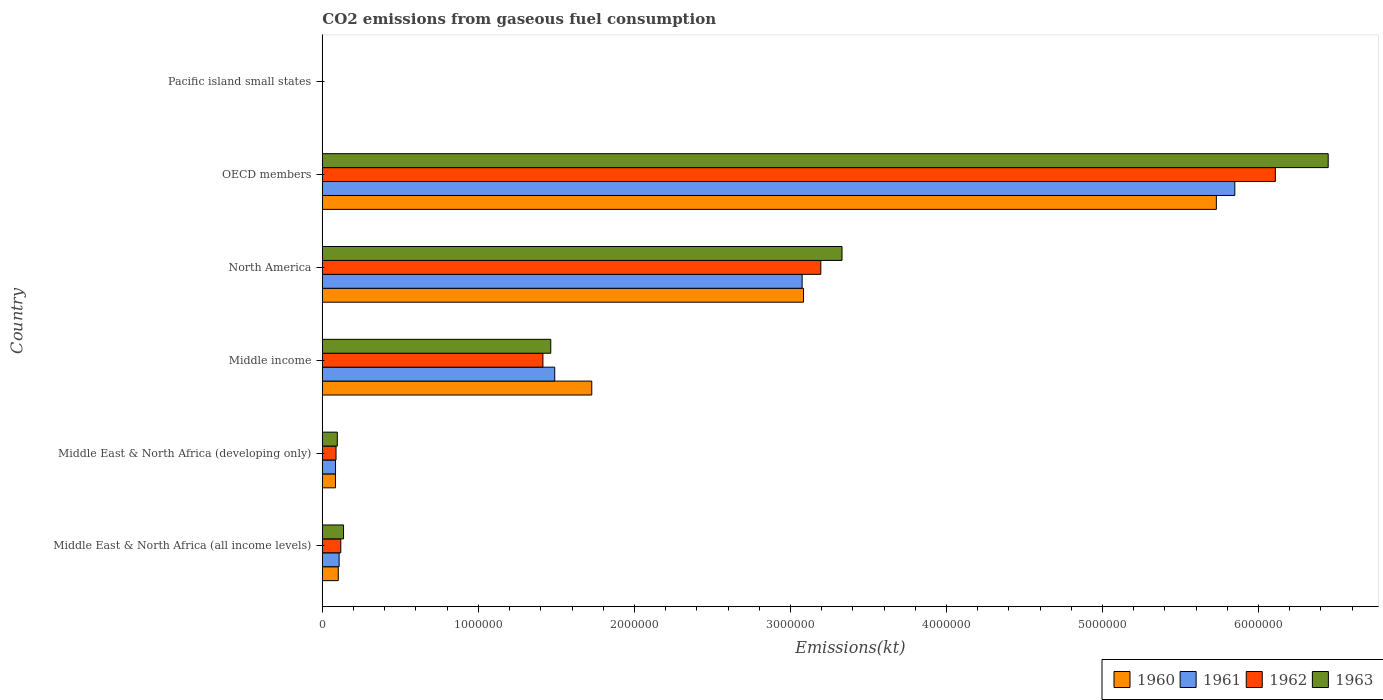How many groups of bars are there?
Make the answer very short. 6. How many bars are there on the 6th tick from the bottom?
Provide a succinct answer. 4. What is the label of the 4th group of bars from the top?
Your answer should be very brief. Middle income. What is the amount of CO2 emitted in 1961 in Middle income?
Make the answer very short. 1.49e+06. Across all countries, what is the maximum amount of CO2 emitted in 1961?
Ensure brevity in your answer.  5.85e+06. Across all countries, what is the minimum amount of CO2 emitted in 1961?
Offer a terse response. 332.61. In which country was the amount of CO2 emitted in 1960 maximum?
Your answer should be compact. OECD members. In which country was the amount of CO2 emitted in 1960 minimum?
Offer a terse response. Pacific island small states. What is the total amount of CO2 emitted in 1960 in the graph?
Keep it short and to the point. 1.07e+07. What is the difference between the amount of CO2 emitted in 1962 in Middle income and that in OECD members?
Offer a terse response. -4.69e+06. What is the difference between the amount of CO2 emitted in 1963 in Middle East & North Africa (all income levels) and the amount of CO2 emitted in 1960 in Middle East & North Africa (developing only)?
Offer a very short reply. 5.17e+04. What is the average amount of CO2 emitted in 1963 per country?
Provide a short and direct response. 1.91e+06. What is the difference between the amount of CO2 emitted in 1961 and amount of CO2 emitted in 1963 in OECD members?
Offer a terse response. -5.99e+05. In how many countries, is the amount of CO2 emitted in 1963 greater than 200000 kt?
Offer a terse response. 3. What is the ratio of the amount of CO2 emitted in 1961 in Middle income to that in North America?
Provide a short and direct response. 0.48. Is the amount of CO2 emitted in 1961 in OECD members less than that in Pacific island small states?
Your response must be concise. No. Is the difference between the amount of CO2 emitted in 1961 in Middle East & North Africa (all income levels) and Middle income greater than the difference between the amount of CO2 emitted in 1963 in Middle East & North Africa (all income levels) and Middle income?
Your response must be concise. No. What is the difference between the highest and the second highest amount of CO2 emitted in 1962?
Provide a short and direct response. 2.91e+06. What is the difference between the highest and the lowest amount of CO2 emitted in 1961?
Make the answer very short. 5.85e+06. In how many countries, is the amount of CO2 emitted in 1960 greater than the average amount of CO2 emitted in 1960 taken over all countries?
Your answer should be compact. 2. Is the sum of the amount of CO2 emitted in 1962 in Middle East & North Africa (all income levels) and Middle East & North Africa (developing only) greater than the maximum amount of CO2 emitted in 1963 across all countries?
Give a very brief answer. No. Is it the case that in every country, the sum of the amount of CO2 emitted in 1963 and amount of CO2 emitted in 1960 is greater than the sum of amount of CO2 emitted in 1962 and amount of CO2 emitted in 1961?
Give a very brief answer. No. What does the 3rd bar from the bottom in OECD members represents?
Provide a short and direct response. 1962. What is the difference between two consecutive major ticks on the X-axis?
Ensure brevity in your answer.  1.00e+06. Are the values on the major ticks of X-axis written in scientific E-notation?
Provide a succinct answer. No. Where does the legend appear in the graph?
Make the answer very short. Bottom right. How are the legend labels stacked?
Make the answer very short. Horizontal. What is the title of the graph?
Give a very brief answer. CO2 emissions from gaseous fuel consumption. Does "2000" appear as one of the legend labels in the graph?
Your answer should be compact. No. What is the label or title of the X-axis?
Provide a short and direct response. Emissions(kt). What is the label or title of the Y-axis?
Your answer should be very brief. Country. What is the Emissions(kt) in 1960 in Middle East & North Africa (all income levels)?
Give a very brief answer. 1.02e+05. What is the Emissions(kt) in 1961 in Middle East & North Africa (all income levels)?
Keep it short and to the point. 1.07e+05. What is the Emissions(kt) of 1962 in Middle East & North Africa (all income levels)?
Keep it short and to the point. 1.18e+05. What is the Emissions(kt) in 1963 in Middle East & North Africa (all income levels)?
Your answer should be very brief. 1.36e+05. What is the Emissions(kt) of 1960 in Middle East & North Africa (developing only)?
Your answer should be compact. 8.42e+04. What is the Emissions(kt) of 1961 in Middle East & North Africa (developing only)?
Offer a terse response. 8.46e+04. What is the Emissions(kt) in 1962 in Middle East & North Africa (developing only)?
Offer a terse response. 8.78e+04. What is the Emissions(kt) in 1963 in Middle East & North Africa (developing only)?
Make the answer very short. 9.60e+04. What is the Emissions(kt) in 1960 in Middle income?
Your answer should be compact. 1.73e+06. What is the Emissions(kt) of 1961 in Middle income?
Your answer should be very brief. 1.49e+06. What is the Emissions(kt) of 1962 in Middle income?
Offer a very short reply. 1.41e+06. What is the Emissions(kt) of 1963 in Middle income?
Keep it short and to the point. 1.46e+06. What is the Emissions(kt) in 1960 in North America?
Offer a very short reply. 3.08e+06. What is the Emissions(kt) in 1961 in North America?
Provide a succinct answer. 3.07e+06. What is the Emissions(kt) of 1962 in North America?
Give a very brief answer. 3.19e+06. What is the Emissions(kt) of 1963 in North America?
Provide a succinct answer. 3.33e+06. What is the Emissions(kt) of 1960 in OECD members?
Your answer should be very brief. 5.73e+06. What is the Emissions(kt) of 1961 in OECD members?
Keep it short and to the point. 5.85e+06. What is the Emissions(kt) of 1962 in OECD members?
Your answer should be compact. 6.11e+06. What is the Emissions(kt) of 1963 in OECD members?
Offer a terse response. 6.45e+06. What is the Emissions(kt) in 1960 in Pacific island small states?
Provide a short and direct response. 309.51. What is the Emissions(kt) of 1961 in Pacific island small states?
Make the answer very short. 332.61. What is the Emissions(kt) in 1962 in Pacific island small states?
Provide a succinct answer. 413.52. What is the Emissions(kt) of 1963 in Pacific island small states?
Keep it short and to the point. 433.59. Across all countries, what is the maximum Emissions(kt) of 1960?
Give a very brief answer. 5.73e+06. Across all countries, what is the maximum Emissions(kt) of 1961?
Your answer should be compact. 5.85e+06. Across all countries, what is the maximum Emissions(kt) of 1962?
Offer a terse response. 6.11e+06. Across all countries, what is the maximum Emissions(kt) of 1963?
Your answer should be very brief. 6.45e+06. Across all countries, what is the minimum Emissions(kt) of 1960?
Offer a very short reply. 309.51. Across all countries, what is the minimum Emissions(kt) of 1961?
Provide a succinct answer. 332.61. Across all countries, what is the minimum Emissions(kt) in 1962?
Keep it short and to the point. 413.52. Across all countries, what is the minimum Emissions(kt) in 1963?
Provide a short and direct response. 433.59. What is the total Emissions(kt) in 1960 in the graph?
Offer a very short reply. 1.07e+07. What is the total Emissions(kt) of 1961 in the graph?
Your response must be concise. 1.06e+07. What is the total Emissions(kt) in 1962 in the graph?
Make the answer very short. 1.09e+07. What is the total Emissions(kt) in 1963 in the graph?
Your answer should be very brief. 1.15e+07. What is the difference between the Emissions(kt) of 1960 in Middle East & North Africa (all income levels) and that in Middle East & North Africa (developing only)?
Your answer should be compact. 1.80e+04. What is the difference between the Emissions(kt) of 1961 in Middle East & North Africa (all income levels) and that in Middle East & North Africa (developing only)?
Your response must be concise. 2.29e+04. What is the difference between the Emissions(kt) in 1962 in Middle East & North Africa (all income levels) and that in Middle East & North Africa (developing only)?
Keep it short and to the point. 3.06e+04. What is the difference between the Emissions(kt) of 1963 in Middle East & North Africa (all income levels) and that in Middle East & North Africa (developing only)?
Provide a short and direct response. 4.00e+04. What is the difference between the Emissions(kt) in 1960 in Middle East & North Africa (all income levels) and that in Middle income?
Provide a succinct answer. -1.62e+06. What is the difference between the Emissions(kt) in 1961 in Middle East & North Africa (all income levels) and that in Middle income?
Provide a short and direct response. -1.38e+06. What is the difference between the Emissions(kt) of 1962 in Middle East & North Africa (all income levels) and that in Middle income?
Offer a very short reply. -1.30e+06. What is the difference between the Emissions(kt) in 1963 in Middle East & North Africa (all income levels) and that in Middle income?
Keep it short and to the point. -1.33e+06. What is the difference between the Emissions(kt) of 1960 in Middle East & North Africa (all income levels) and that in North America?
Offer a terse response. -2.98e+06. What is the difference between the Emissions(kt) in 1961 in Middle East & North Africa (all income levels) and that in North America?
Give a very brief answer. -2.97e+06. What is the difference between the Emissions(kt) in 1962 in Middle East & North Africa (all income levels) and that in North America?
Provide a short and direct response. -3.08e+06. What is the difference between the Emissions(kt) of 1963 in Middle East & North Africa (all income levels) and that in North America?
Provide a succinct answer. -3.19e+06. What is the difference between the Emissions(kt) of 1960 in Middle East & North Africa (all income levels) and that in OECD members?
Make the answer very short. -5.63e+06. What is the difference between the Emissions(kt) in 1961 in Middle East & North Africa (all income levels) and that in OECD members?
Your answer should be very brief. -5.74e+06. What is the difference between the Emissions(kt) of 1962 in Middle East & North Africa (all income levels) and that in OECD members?
Provide a short and direct response. -5.99e+06. What is the difference between the Emissions(kt) of 1963 in Middle East & North Africa (all income levels) and that in OECD members?
Offer a terse response. -6.31e+06. What is the difference between the Emissions(kt) of 1960 in Middle East & North Africa (all income levels) and that in Pacific island small states?
Your answer should be compact. 1.02e+05. What is the difference between the Emissions(kt) in 1961 in Middle East & North Africa (all income levels) and that in Pacific island small states?
Your answer should be very brief. 1.07e+05. What is the difference between the Emissions(kt) of 1962 in Middle East & North Africa (all income levels) and that in Pacific island small states?
Ensure brevity in your answer.  1.18e+05. What is the difference between the Emissions(kt) in 1963 in Middle East & North Africa (all income levels) and that in Pacific island small states?
Provide a succinct answer. 1.36e+05. What is the difference between the Emissions(kt) of 1960 in Middle East & North Africa (developing only) and that in Middle income?
Keep it short and to the point. -1.64e+06. What is the difference between the Emissions(kt) in 1961 in Middle East & North Africa (developing only) and that in Middle income?
Your answer should be very brief. -1.40e+06. What is the difference between the Emissions(kt) of 1962 in Middle East & North Africa (developing only) and that in Middle income?
Offer a very short reply. -1.33e+06. What is the difference between the Emissions(kt) of 1963 in Middle East & North Africa (developing only) and that in Middle income?
Your response must be concise. -1.37e+06. What is the difference between the Emissions(kt) in 1960 in Middle East & North Africa (developing only) and that in North America?
Give a very brief answer. -3.00e+06. What is the difference between the Emissions(kt) in 1961 in Middle East & North Africa (developing only) and that in North America?
Your answer should be compact. -2.99e+06. What is the difference between the Emissions(kt) of 1962 in Middle East & North Africa (developing only) and that in North America?
Keep it short and to the point. -3.11e+06. What is the difference between the Emissions(kt) in 1963 in Middle East & North Africa (developing only) and that in North America?
Offer a very short reply. -3.23e+06. What is the difference between the Emissions(kt) in 1960 in Middle East & North Africa (developing only) and that in OECD members?
Provide a short and direct response. -5.65e+06. What is the difference between the Emissions(kt) in 1961 in Middle East & North Africa (developing only) and that in OECD members?
Provide a succinct answer. -5.76e+06. What is the difference between the Emissions(kt) in 1962 in Middle East & North Africa (developing only) and that in OECD members?
Provide a succinct answer. -6.02e+06. What is the difference between the Emissions(kt) in 1963 in Middle East & North Africa (developing only) and that in OECD members?
Make the answer very short. -6.35e+06. What is the difference between the Emissions(kt) in 1960 in Middle East & North Africa (developing only) and that in Pacific island small states?
Make the answer very short. 8.39e+04. What is the difference between the Emissions(kt) in 1961 in Middle East & North Africa (developing only) and that in Pacific island small states?
Offer a terse response. 8.43e+04. What is the difference between the Emissions(kt) of 1962 in Middle East & North Africa (developing only) and that in Pacific island small states?
Provide a short and direct response. 8.74e+04. What is the difference between the Emissions(kt) of 1963 in Middle East & North Africa (developing only) and that in Pacific island small states?
Provide a short and direct response. 9.56e+04. What is the difference between the Emissions(kt) in 1960 in Middle income and that in North America?
Offer a terse response. -1.36e+06. What is the difference between the Emissions(kt) in 1961 in Middle income and that in North America?
Your response must be concise. -1.59e+06. What is the difference between the Emissions(kt) of 1962 in Middle income and that in North America?
Your answer should be very brief. -1.78e+06. What is the difference between the Emissions(kt) of 1963 in Middle income and that in North America?
Your answer should be very brief. -1.87e+06. What is the difference between the Emissions(kt) in 1960 in Middle income and that in OECD members?
Ensure brevity in your answer.  -4.00e+06. What is the difference between the Emissions(kt) in 1961 in Middle income and that in OECD members?
Offer a very short reply. -4.36e+06. What is the difference between the Emissions(kt) in 1962 in Middle income and that in OECD members?
Keep it short and to the point. -4.69e+06. What is the difference between the Emissions(kt) of 1963 in Middle income and that in OECD members?
Your response must be concise. -4.98e+06. What is the difference between the Emissions(kt) of 1960 in Middle income and that in Pacific island small states?
Your answer should be compact. 1.73e+06. What is the difference between the Emissions(kt) of 1961 in Middle income and that in Pacific island small states?
Ensure brevity in your answer.  1.49e+06. What is the difference between the Emissions(kt) of 1962 in Middle income and that in Pacific island small states?
Your answer should be very brief. 1.41e+06. What is the difference between the Emissions(kt) in 1963 in Middle income and that in Pacific island small states?
Your answer should be very brief. 1.46e+06. What is the difference between the Emissions(kt) of 1960 in North America and that in OECD members?
Ensure brevity in your answer.  -2.65e+06. What is the difference between the Emissions(kt) in 1961 in North America and that in OECD members?
Your answer should be very brief. -2.77e+06. What is the difference between the Emissions(kt) in 1962 in North America and that in OECD members?
Your response must be concise. -2.91e+06. What is the difference between the Emissions(kt) in 1963 in North America and that in OECD members?
Keep it short and to the point. -3.12e+06. What is the difference between the Emissions(kt) in 1960 in North America and that in Pacific island small states?
Your answer should be compact. 3.08e+06. What is the difference between the Emissions(kt) of 1961 in North America and that in Pacific island small states?
Your response must be concise. 3.07e+06. What is the difference between the Emissions(kt) in 1962 in North America and that in Pacific island small states?
Offer a terse response. 3.19e+06. What is the difference between the Emissions(kt) of 1963 in North America and that in Pacific island small states?
Provide a succinct answer. 3.33e+06. What is the difference between the Emissions(kt) in 1960 in OECD members and that in Pacific island small states?
Give a very brief answer. 5.73e+06. What is the difference between the Emissions(kt) of 1961 in OECD members and that in Pacific island small states?
Ensure brevity in your answer.  5.85e+06. What is the difference between the Emissions(kt) in 1962 in OECD members and that in Pacific island small states?
Your answer should be very brief. 6.11e+06. What is the difference between the Emissions(kt) in 1963 in OECD members and that in Pacific island small states?
Ensure brevity in your answer.  6.45e+06. What is the difference between the Emissions(kt) of 1960 in Middle East & North Africa (all income levels) and the Emissions(kt) of 1961 in Middle East & North Africa (developing only)?
Your answer should be compact. 1.76e+04. What is the difference between the Emissions(kt) of 1960 in Middle East & North Africa (all income levels) and the Emissions(kt) of 1962 in Middle East & North Africa (developing only)?
Provide a short and direct response. 1.45e+04. What is the difference between the Emissions(kt) in 1960 in Middle East & North Africa (all income levels) and the Emissions(kt) in 1963 in Middle East & North Africa (developing only)?
Keep it short and to the point. 6263.25. What is the difference between the Emissions(kt) of 1961 in Middle East & North Africa (all income levels) and the Emissions(kt) of 1962 in Middle East & North Africa (developing only)?
Offer a terse response. 1.97e+04. What is the difference between the Emissions(kt) of 1961 in Middle East & North Africa (all income levels) and the Emissions(kt) of 1963 in Middle East & North Africa (developing only)?
Offer a terse response. 1.15e+04. What is the difference between the Emissions(kt) of 1962 in Middle East & North Africa (all income levels) and the Emissions(kt) of 1963 in Middle East & North Africa (developing only)?
Your answer should be compact. 2.24e+04. What is the difference between the Emissions(kt) of 1960 in Middle East & North Africa (all income levels) and the Emissions(kt) of 1961 in Middle income?
Offer a terse response. -1.39e+06. What is the difference between the Emissions(kt) of 1960 in Middle East & North Africa (all income levels) and the Emissions(kt) of 1962 in Middle income?
Make the answer very short. -1.31e+06. What is the difference between the Emissions(kt) of 1960 in Middle East & North Africa (all income levels) and the Emissions(kt) of 1963 in Middle income?
Offer a very short reply. -1.36e+06. What is the difference between the Emissions(kt) in 1961 in Middle East & North Africa (all income levels) and the Emissions(kt) in 1962 in Middle income?
Your answer should be compact. -1.31e+06. What is the difference between the Emissions(kt) of 1961 in Middle East & North Africa (all income levels) and the Emissions(kt) of 1963 in Middle income?
Keep it short and to the point. -1.36e+06. What is the difference between the Emissions(kt) of 1962 in Middle East & North Africa (all income levels) and the Emissions(kt) of 1963 in Middle income?
Your answer should be very brief. -1.35e+06. What is the difference between the Emissions(kt) of 1960 in Middle East & North Africa (all income levels) and the Emissions(kt) of 1961 in North America?
Ensure brevity in your answer.  -2.97e+06. What is the difference between the Emissions(kt) in 1960 in Middle East & North Africa (all income levels) and the Emissions(kt) in 1962 in North America?
Your response must be concise. -3.09e+06. What is the difference between the Emissions(kt) of 1960 in Middle East & North Africa (all income levels) and the Emissions(kt) of 1963 in North America?
Offer a terse response. -3.23e+06. What is the difference between the Emissions(kt) of 1961 in Middle East & North Africa (all income levels) and the Emissions(kt) of 1962 in North America?
Give a very brief answer. -3.09e+06. What is the difference between the Emissions(kt) of 1961 in Middle East & North Africa (all income levels) and the Emissions(kt) of 1963 in North America?
Provide a succinct answer. -3.22e+06. What is the difference between the Emissions(kt) in 1962 in Middle East & North Africa (all income levels) and the Emissions(kt) in 1963 in North America?
Keep it short and to the point. -3.21e+06. What is the difference between the Emissions(kt) of 1960 in Middle East & North Africa (all income levels) and the Emissions(kt) of 1961 in OECD members?
Your answer should be compact. -5.75e+06. What is the difference between the Emissions(kt) in 1960 in Middle East & North Africa (all income levels) and the Emissions(kt) in 1962 in OECD members?
Keep it short and to the point. -6.01e+06. What is the difference between the Emissions(kt) of 1960 in Middle East & North Africa (all income levels) and the Emissions(kt) of 1963 in OECD members?
Your answer should be compact. -6.34e+06. What is the difference between the Emissions(kt) in 1961 in Middle East & North Africa (all income levels) and the Emissions(kt) in 1962 in OECD members?
Your answer should be very brief. -6.00e+06. What is the difference between the Emissions(kt) in 1961 in Middle East & North Africa (all income levels) and the Emissions(kt) in 1963 in OECD members?
Offer a terse response. -6.34e+06. What is the difference between the Emissions(kt) in 1962 in Middle East & North Africa (all income levels) and the Emissions(kt) in 1963 in OECD members?
Provide a succinct answer. -6.33e+06. What is the difference between the Emissions(kt) of 1960 in Middle East & North Africa (all income levels) and the Emissions(kt) of 1961 in Pacific island small states?
Your response must be concise. 1.02e+05. What is the difference between the Emissions(kt) of 1960 in Middle East & North Africa (all income levels) and the Emissions(kt) of 1962 in Pacific island small states?
Make the answer very short. 1.02e+05. What is the difference between the Emissions(kt) in 1960 in Middle East & North Africa (all income levels) and the Emissions(kt) in 1963 in Pacific island small states?
Ensure brevity in your answer.  1.02e+05. What is the difference between the Emissions(kt) of 1961 in Middle East & North Africa (all income levels) and the Emissions(kt) of 1962 in Pacific island small states?
Ensure brevity in your answer.  1.07e+05. What is the difference between the Emissions(kt) of 1961 in Middle East & North Africa (all income levels) and the Emissions(kt) of 1963 in Pacific island small states?
Offer a very short reply. 1.07e+05. What is the difference between the Emissions(kt) in 1962 in Middle East & North Africa (all income levels) and the Emissions(kt) in 1963 in Pacific island small states?
Provide a short and direct response. 1.18e+05. What is the difference between the Emissions(kt) of 1960 in Middle East & North Africa (developing only) and the Emissions(kt) of 1961 in Middle income?
Your response must be concise. -1.41e+06. What is the difference between the Emissions(kt) in 1960 in Middle East & North Africa (developing only) and the Emissions(kt) in 1962 in Middle income?
Offer a very short reply. -1.33e+06. What is the difference between the Emissions(kt) of 1960 in Middle East & North Africa (developing only) and the Emissions(kt) of 1963 in Middle income?
Your response must be concise. -1.38e+06. What is the difference between the Emissions(kt) of 1961 in Middle East & North Africa (developing only) and the Emissions(kt) of 1962 in Middle income?
Provide a succinct answer. -1.33e+06. What is the difference between the Emissions(kt) in 1961 in Middle East & North Africa (developing only) and the Emissions(kt) in 1963 in Middle income?
Make the answer very short. -1.38e+06. What is the difference between the Emissions(kt) of 1962 in Middle East & North Africa (developing only) and the Emissions(kt) of 1963 in Middle income?
Make the answer very short. -1.38e+06. What is the difference between the Emissions(kt) in 1960 in Middle East & North Africa (developing only) and the Emissions(kt) in 1961 in North America?
Your answer should be compact. -2.99e+06. What is the difference between the Emissions(kt) of 1960 in Middle East & North Africa (developing only) and the Emissions(kt) of 1962 in North America?
Your answer should be very brief. -3.11e+06. What is the difference between the Emissions(kt) in 1960 in Middle East & North Africa (developing only) and the Emissions(kt) in 1963 in North America?
Ensure brevity in your answer.  -3.25e+06. What is the difference between the Emissions(kt) in 1961 in Middle East & North Africa (developing only) and the Emissions(kt) in 1962 in North America?
Make the answer very short. -3.11e+06. What is the difference between the Emissions(kt) of 1961 in Middle East & North Africa (developing only) and the Emissions(kt) of 1963 in North America?
Keep it short and to the point. -3.25e+06. What is the difference between the Emissions(kt) in 1962 in Middle East & North Africa (developing only) and the Emissions(kt) in 1963 in North America?
Give a very brief answer. -3.24e+06. What is the difference between the Emissions(kt) of 1960 in Middle East & North Africa (developing only) and the Emissions(kt) of 1961 in OECD members?
Your answer should be very brief. -5.76e+06. What is the difference between the Emissions(kt) in 1960 in Middle East & North Africa (developing only) and the Emissions(kt) in 1962 in OECD members?
Provide a short and direct response. -6.02e+06. What is the difference between the Emissions(kt) of 1960 in Middle East & North Africa (developing only) and the Emissions(kt) of 1963 in OECD members?
Provide a short and direct response. -6.36e+06. What is the difference between the Emissions(kt) of 1961 in Middle East & North Africa (developing only) and the Emissions(kt) of 1962 in OECD members?
Give a very brief answer. -6.02e+06. What is the difference between the Emissions(kt) of 1961 in Middle East & North Africa (developing only) and the Emissions(kt) of 1963 in OECD members?
Your answer should be compact. -6.36e+06. What is the difference between the Emissions(kt) of 1962 in Middle East & North Africa (developing only) and the Emissions(kt) of 1963 in OECD members?
Ensure brevity in your answer.  -6.36e+06. What is the difference between the Emissions(kt) of 1960 in Middle East & North Africa (developing only) and the Emissions(kt) of 1961 in Pacific island small states?
Your response must be concise. 8.39e+04. What is the difference between the Emissions(kt) of 1960 in Middle East & North Africa (developing only) and the Emissions(kt) of 1962 in Pacific island small states?
Offer a very short reply. 8.38e+04. What is the difference between the Emissions(kt) in 1960 in Middle East & North Africa (developing only) and the Emissions(kt) in 1963 in Pacific island small states?
Your response must be concise. 8.38e+04. What is the difference between the Emissions(kt) of 1961 in Middle East & North Africa (developing only) and the Emissions(kt) of 1962 in Pacific island small states?
Offer a terse response. 8.42e+04. What is the difference between the Emissions(kt) in 1961 in Middle East & North Africa (developing only) and the Emissions(kt) in 1963 in Pacific island small states?
Keep it short and to the point. 8.42e+04. What is the difference between the Emissions(kt) in 1962 in Middle East & North Africa (developing only) and the Emissions(kt) in 1963 in Pacific island small states?
Give a very brief answer. 8.73e+04. What is the difference between the Emissions(kt) of 1960 in Middle income and the Emissions(kt) of 1961 in North America?
Offer a terse response. -1.35e+06. What is the difference between the Emissions(kt) of 1960 in Middle income and the Emissions(kt) of 1962 in North America?
Provide a succinct answer. -1.47e+06. What is the difference between the Emissions(kt) of 1960 in Middle income and the Emissions(kt) of 1963 in North America?
Your answer should be very brief. -1.60e+06. What is the difference between the Emissions(kt) in 1961 in Middle income and the Emissions(kt) in 1962 in North America?
Offer a very short reply. -1.71e+06. What is the difference between the Emissions(kt) in 1961 in Middle income and the Emissions(kt) in 1963 in North America?
Keep it short and to the point. -1.84e+06. What is the difference between the Emissions(kt) in 1962 in Middle income and the Emissions(kt) in 1963 in North America?
Make the answer very short. -1.92e+06. What is the difference between the Emissions(kt) in 1960 in Middle income and the Emissions(kt) in 1961 in OECD members?
Provide a short and direct response. -4.12e+06. What is the difference between the Emissions(kt) of 1960 in Middle income and the Emissions(kt) of 1962 in OECD members?
Make the answer very short. -4.38e+06. What is the difference between the Emissions(kt) in 1960 in Middle income and the Emissions(kt) in 1963 in OECD members?
Offer a terse response. -4.72e+06. What is the difference between the Emissions(kt) of 1961 in Middle income and the Emissions(kt) of 1962 in OECD members?
Your answer should be compact. -4.62e+06. What is the difference between the Emissions(kt) of 1961 in Middle income and the Emissions(kt) of 1963 in OECD members?
Provide a succinct answer. -4.96e+06. What is the difference between the Emissions(kt) of 1962 in Middle income and the Emissions(kt) of 1963 in OECD members?
Offer a very short reply. -5.03e+06. What is the difference between the Emissions(kt) of 1960 in Middle income and the Emissions(kt) of 1961 in Pacific island small states?
Your answer should be compact. 1.73e+06. What is the difference between the Emissions(kt) in 1960 in Middle income and the Emissions(kt) in 1962 in Pacific island small states?
Ensure brevity in your answer.  1.73e+06. What is the difference between the Emissions(kt) of 1960 in Middle income and the Emissions(kt) of 1963 in Pacific island small states?
Your response must be concise. 1.73e+06. What is the difference between the Emissions(kt) of 1961 in Middle income and the Emissions(kt) of 1962 in Pacific island small states?
Provide a succinct answer. 1.49e+06. What is the difference between the Emissions(kt) in 1961 in Middle income and the Emissions(kt) in 1963 in Pacific island small states?
Your response must be concise. 1.49e+06. What is the difference between the Emissions(kt) of 1962 in Middle income and the Emissions(kt) of 1963 in Pacific island small states?
Offer a terse response. 1.41e+06. What is the difference between the Emissions(kt) in 1960 in North America and the Emissions(kt) in 1961 in OECD members?
Your answer should be compact. -2.76e+06. What is the difference between the Emissions(kt) in 1960 in North America and the Emissions(kt) in 1962 in OECD members?
Keep it short and to the point. -3.02e+06. What is the difference between the Emissions(kt) in 1960 in North America and the Emissions(kt) in 1963 in OECD members?
Offer a very short reply. -3.36e+06. What is the difference between the Emissions(kt) of 1961 in North America and the Emissions(kt) of 1962 in OECD members?
Make the answer very short. -3.03e+06. What is the difference between the Emissions(kt) in 1961 in North America and the Emissions(kt) in 1963 in OECD members?
Your response must be concise. -3.37e+06. What is the difference between the Emissions(kt) of 1962 in North America and the Emissions(kt) of 1963 in OECD members?
Keep it short and to the point. -3.25e+06. What is the difference between the Emissions(kt) in 1960 in North America and the Emissions(kt) in 1961 in Pacific island small states?
Offer a terse response. 3.08e+06. What is the difference between the Emissions(kt) of 1960 in North America and the Emissions(kt) of 1962 in Pacific island small states?
Your answer should be compact. 3.08e+06. What is the difference between the Emissions(kt) of 1960 in North America and the Emissions(kt) of 1963 in Pacific island small states?
Provide a succinct answer. 3.08e+06. What is the difference between the Emissions(kt) of 1961 in North America and the Emissions(kt) of 1962 in Pacific island small states?
Provide a short and direct response. 3.07e+06. What is the difference between the Emissions(kt) of 1961 in North America and the Emissions(kt) of 1963 in Pacific island small states?
Make the answer very short. 3.07e+06. What is the difference between the Emissions(kt) of 1962 in North America and the Emissions(kt) of 1963 in Pacific island small states?
Offer a terse response. 3.19e+06. What is the difference between the Emissions(kt) of 1960 in OECD members and the Emissions(kt) of 1961 in Pacific island small states?
Make the answer very short. 5.73e+06. What is the difference between the Emissions(kt) in 1960 in OECD members and the Emissions(kt) in 1962 in Pacific island small states?
Provide a short and direct response. 5.73e+06. What is the difference between the Emissions(kt) of 1960 in OECD members and the Emissions(kt) of 1963 in Pacific island small states?
Offer a very short reply. 5.73e+06. What is the difference between the Emissions(kt) of 1961 in OECD members and the Emissions(kt) of 1962 in Pacific island small states?
Provide a short and direct response. 5.85e+06. What is the difference between the Emissions(kt) of 1961 in OECD members and the Emissions(kt) of 1963 in Pacific island small states?
Your answer should be compact. 5.85e+06. What is the difference between the Emissions(kt) in 1962 in OECD members and the Emissions(kt) in 1963 in Pacific island small states?
Keep it short and to the point. 6.11e+06. What is the average Emissions(kt) of 1960 per country?
Your response must be concise. 1.79e+06. What is the average Emissions(kt) in 1961 per country?
Provide a short and direct response. 1.77e+06. What is the average Emissions(kt) of 1962 per country?
Offer a very short reply. 1.82e+06. What is the average Emissions(kt) in 1963 per country?
Make the answer very short. 1.91e+06. What is the difference between the Emissions(kt) in 1960 and Emissions(kt) in 1961 in Middle East & North Africa (all income levels)?
Provide a succinct answer. -5245.97. What is the difference between the Emissions(kt) in 1960 and Emissions(kt) in 1962 in Middle East & North Africa (all income levels)?
Provide a succinct answer. -1.61e+04. What is the difference between the Emissions(kt) in 1960 and Emissions(kt) in 1963 in Middle East & North Africa (all income levels)?
Your answer should be very brief. -3.37e+04. What is the difference between the Emissions(kt) of 1961 and Emissions(kt) of 1962 in Middle East & North Africa (all income levels)?
Your answer should be compact. -1.09e+04. What is the difference between the Emissions(kt) in 1961 and Emissions(kt) in 1963 in Middle East & North Africa (all income levels)?
Give a very brief answer. -2.84e+04. What is the difference between the Emissions(kt) of 1962 and Emissions(kt) of 1963 in Middle East & North Africa (all income levels)?
Your response must be concise. -1.75e+04. What is the difference between the Emissions(kt) in 1960 and Emissions(kt) in 1961 in Middle East & North Africa (developing only)?
Your answer should be very brief. -436.61. What is the difference between the Emissions(kt) in 1960 and Emissions(kt) in 1962 in Middle East & North Africa (developing only)?
Your answer should be very brief. -3573.64. What is the difference between the Emissions(kt) of 1960 and Emissions(kt) of 1963 in Middle East & North Africa (developing only)?
Provide a short and direct response. -1.18e+04. What is the difference between the Emissions(kt) of 1961 and Emissions(kt) of 1962 in Middle East & North Africa (developing only)?
Give a very brief answer. -3137.02. What is the difference between the Emissions(kt) of 1961 and Emissions(kt) of 1963 in Middle East & North Africa (developing only)?
Your response must be concise. -1.13e+04. What is the difference between the Emissions(kt) of 1962 and Emissions(kt) of 1963 in Middle East & North Africa (developing only)?
Give a very brief answer. -8211.29. What is the difference between the Emissions(kt) in 1960 and Emissions(kt) in 1961 in Middle income?
Your answer should be compact. 2.37e+05. What is the difference between the Emissions(kt) of 1960 and Emissions(kt) of 1962 in Middle income?
Your answer should be very brief. 3.13e+05. What is the difference between the Emissions(kt) in 1960 and Emissions(kt) in 1963 in Middle income?
Your answer should be very brief. 2.63e+05. What is the difference between the Emissions(kt) of 1961 and Emissions(kt) of 1962 in Middle income?
Provide a short and direct response. 7.58e+04. What is the difference between the Emissions(kt) of 1961 and Emissions(kt) of 1963 in Middle income?
Ensure brevity in your answer.  2.55e+04. What is the difference between the Emissions(kt) in 1962 and Emissions(kt) in 1963 in Middle income?
Your answer should be compact. -5.03e+04. What is the difference between the Emissions(kt) in 1960 and Emissions(kt) in 1961 in North America?
Give a very brief answer. 8885.14. What is the difference between the Emissions(kt) of 1960 and Emissions(kt) of 1962 in North America?
Give a very brief answer. -1.11e+05. What is the difference between the Emissions(kt) of 1960 and Emissions(kt) of 1963 in North America?
Your answer should be very brief. -2.47e+05. What is the difference between the Emissions(kt) in 1961 and Emissions(kt) in 1962 in North America?
Give a very brief answer. -1.20e+05. What is the difference between the Emissions(kt) of 1961 and Emissions(kt) of 1963 in North America?
Offer a terse response. -2.56e+05. What is the difference between the Emissions(kt) in 1962 and Emissions(kt) in 1963 in North America?
Your response must be concise. -1.36e+05. What is the difference between the Emissions(kt) in 1960 and Emissions(kt) in 1961 in OECD members?
Make the answer very short. -1.18e+05. What is the difference between the Emissions(kt) of 1960 and Emissions(kt) of 1962 in OECD members?
Your answer should be compact. -3.78e+05. What is the difference between the Emissions(kt) of 1960 and Emissions(kt) of 1963 in OECD members?
Provide a succinct answer. -7.17e+05. What is the difference between the Emissions(kt) of 1961 and Emissions(kt) of 1962 in OECD members?
Offer a very short reply. -2.60e+05. What is the difference between the Emissions(kt) in 1961 and Emissions(kt) in 1963 in OECD members?
Make the answer very short. -5.99e+05. What is the difference between the Emissions(kt) in 1962 and Emissions(kt) in 1963 in OECD members?
Keep it short and to the point. -3.39e+05. What is the difference between the Emissions(kt) of 1960 and Emissions(kt) of 1961 in Pacific island small states?
Your answer should be very brief. -23.1. What is the difference between the Emissions(kt) of 1960 and Emissions(kt) of 1962 in Pacific island small states?
Make the answer very short. -104. What is the difference between the Emissions(kt) of 1960 and Emissions(kt) of 1963 in Pacific island small states?
Your answer should be very brief. -124.08. What is the difference between the Emissions(kt) in 1961 and Emissions(kt) in 1962 in Pacific island small states?
Your answer should be very brief. -80.91. What is the difference between the Emissions(kt) in 1961 and Emissions(kt) in 1963 in Pacific island small states?
Your answer should be compact. -100.98. What is the difference between the Emissions(kt) of 1962 and Emissions(kt) of 1963 in Pacific island small states?
Offer a terse response. -20.07. What is the ratio of the Emissions(kt) of 1960 in Middle East & North Africa (all income levels) to that in Middle East & North Africa (developing only)?
Give a very brief answer. 1.21. What is the ratio of the Emissions(kt) in 1961 in Middle East & North Africa (all income levels) to that in Middle East & North Africa (developing only)?
Provide a succinct answer. 1.27. What is the ratio of the Emissions(kt) in 1962 in Middle East & North Africa (all income levels) to that in Middle East & North Africa (developing only)?
Make the answer very short. 1.35. What is the ratio of the Emissions(kt) in 1963 in Middle East & North Africa (all income levels) to that in Middle East & North Africa (developing only)?
Ensure brevity in your answer.  1.42. What is the ratio of the Emissions(kt) in 1960 in Middle East & North Africa (all income levels) to that in Middle income?
Ensure brevity in your answer.  0.06. What is the ratio of the Emissions(kt) in 1961 in Middle East & North Africa (all income levels) to that in Middle income?
Your response must be concise. 0.07. What is the ratio of the Emissions(kt) of 1962 in Middle East & North Africa (all income levels) to that in Middle income?
Offer a very short reply. 0.08. What is the ratio of the Emissions(kt) of 1963 in Middle East & North Africa (all income levels) to that in Middle income?
Make the answer very short. 0.09. What is the ratio of the Emissions(kt) in 1960 in Middle East & North Africa (all income levels) to that in North America?
Your response must be concise. 0.03. What is the ratio of the Emissions(kt) of 1961 in Middle East & North Africa (all income levels) to that in North America?
Make the answer very short. 0.04. What is the ratio of the Emissions(kt) of 1962 in Middle East & North Africa (all income levels) to that in North America?
Provide a succinct answer. 0.04. What is the ratio of the Emissions(kt) in 1963 in Middle East & North Africa (all income levels) to that in North America?
Provide a short and direct response. 0.04. What is the ratio of the Emissions(kt) of 1960 in Middle East & North Africa (all income levels) to that in OECD members?
Give a very brief answer. 0.02. What is the ratio of the Emissions(kt) in 1961 in Middle East & North Africa (all income levels) to that in OECD members?
Give a very brief answer. 0.02. What is the ratio of the Emissions(kt) of 1962 in Middle East & North Africa (all income levels) to that in OECD members?
Keep it short and to the point. 0.02. What is the ratio of the Emissions(kt) in 1963 in Middle East & North Africa (all income levels) to that in OECD members?
Ensure brevity in your answer.  0.02. What is the ratio of the Emissions(kt) of 1960 in Middle East & North Africa (all income levels) to that in Pacific island small states?
Make the answer very short. 330.36. What is the ratio of the Emissions(kt) in 1961 in Middle East & North Africa (all income levels) to that in Pacific island small states?
Offer a terse response. 323.19. What is the ratio of the Emissions(kt) in 1962 in Middle East & North Africa (all income levels) to that in Pacific island small states?
Your answer should be compact. 286.32. What is the ratio of the Emissions(kt) in 1963 in Middle East & North Africa (all income levels) to that in Pacific island small states?
Provide a succinct answer. 313.52. What is the ratio of the Emissions(kt) of 1960 in Middle East & North Africa (developing only) to that in Middle income?
Your answer should be compact. 0.05. What is the ratio of the Emissions(kt) in 1961 in Middle East & North Africa (developing only) to that in Middle income?
Make the answer very short. 0.06. What is the ratio of the Emissions(kt) in 1962 in Middle East & North Africa (developing only) to that in Middle income?
Keep it short and to the point. 0.06. What is the ratio of the Emissions(kt) in 1963 in Middle East & North Africa (developing only) to that in Middle income?
Provide a short and direct response. 0.07. What is the ratio of the Emissions(kt) in 1960 in Middle East & North Africa (developing only) to that in North America?
Give a very brief answer. 0.03. What is the ratio of the Emissions(kt) in 1961 in Middle East & North Africa (developing only) to that in North America?
Offer a very short reply. 0.03. What is the ratio of the Emissions(kt) of 1962 in Middle East & North Africa (developing only) to that in North America?
Offer a very short reply. 0.03. What is the ratio of the Emissions(kt) of 1963 in Middle East & North Africa (developing only) to that in North America?
Offer a terse response. 0.03. What is the ratio of the Emissions(kt) in 1960 in Middle East & North Africa (developing only) to that in OECD members?
Keep it short and to the point. 0.01. What is the ratio of the Emissions(kt) in 1961 in Middle East & North Africa (developing only) to that in OECD members?
Your response must be concise. 0.01. What is the ratio of the Emissions(kt) in 1962 in Middle East & North Africa (developing only) to that in OECD members?
Ensure brevity in your answer.  0.01. What is the ratio of the Emissions(kt) in 1963 in Middle East & North Africa (developing only) to that in OECD members?
Your answer should be very brief. 0.01. What is the ratio of the Emissions(kt) in 1960 in Middle East & North Africa (developing only) to that in Pacific island small states?
Your answer should be compact. 272.05. What is the ratio of the Emissions(kt) of 1961 in Middle East & North Africa (developing only) to that in Pacific island small states?
Offer a terse response. 254.47. What is the ratio of the Emissions(kt) of 1962 in Middle East & North Africa (developing only) to that in Pacific island small states?
Provide a succinct answer. 212.27. What is the ratio of the Emissions(kt) of 1963 in Middle East & North Africa (developing only) to that in Pacific island small states?
Offer a terse response. 221.38. What is the ratio of the Emissions(kt) of 1960 in Middle income to that in North America?
Your answer should be very brief. 0.56. What is the ratio of the Emissions(kt) of 1961 in Middle income to that in North America?
Your answer should be compact. 0.48. What is the ratio of the Emissions(kt) of 1962 in Middle income to that in North America?
Offer a very short reply. 0.44. What is the ratio of the Emissions(kt) in 1963 in Middle income to that in North America?
Give a very brief answer. 0.44. What is the ratio of the Emissions(kt) of 1960 in Middle income to that in OECD members?
Offer a very short reply. 0.3. What is the ratio of the Emissions(kt) of 1961 in Middle income to that in OECD members?
Keep it short and to the point. 0.25. What is the ratio of the Emissions(kt) in 1962 in Middle income to that in OECD members?
Offer a very short reply. 0.23. What is the ratio of the Emissions(kt) of 1963 in Middle income to that in OECD members?
Offer a terse response. 0.23. What is the ratio of the Emissions(kt) of 1960 in Middle income to that in Pacific island small states?
Ensure brevity in your answer.  5578.77. What is the ratio of the Emissions(kt) of 1961 in Middle income to that in Pacific island small states?
Your response must be concise. 4477.99. What is the ratio of the Emissions(kt) in 1962 in Middle income to that in Pacific island small states?
Make the answer very short. 3418.64. What is the ratio of the Emissions(kt) of 1963 in Middle income to that in Pacific island small states?
Ensure brevity in your answer.  3376.33. What is the ratio of the Emissions(kt) of 1960 in North America to that in OECD members?
Provide a short and direct response. 0.54. What is the ratio of the Emissions(kt) of 1961 in North America to that in OECD members?
Provide a short and direct response. 0.53. What is the ratio of the Emissions(kt) of 1962 in North America to that in OECD members?
Keep it short and to the point. 0.52. What is the ratio of the Emissions(kt) of 1963 in North America to that in OECD members?
Make the answer very short. 0.52. What is the ratio of the Emissions(kt) in 1960 in North America to that in Pacific island small states?
Your answer should be very brief. 9963.19. What is the ratio of the Emissions(kt) of 1961 in North America to that in Pacific island small states?
Your answer should be very brief. 9244.59. What is the ratio of the Emissions(kt) of 1962 in North America to that in Pacific island small states?
Provide a short and direct response. 7725.3. What is the ratio of the Emissions(kt) of 1963 in North America to that in Pacific island small states?
Provide a succinct answer. 7681.17. What is the ratio of the Emissions(kt) of 1960 in OECD members to that in Pacific island small states?
Make the answer very short. 1.85e+04. What is the ratio of the Emissions(kt) of 1961 in OECD members to that in Pacific island small states?
Make the answer very short. 1.76e+04. What is the ratio of the Emissions(kt) in 1962 in OECD members to that in Pacific island small states?
Your response must be concise. 1.48e+04. What is the ratio of the Emissions(kt) in 1963 in OECD members to that in Pacific island small states?
Your answer should be very brief. 1.49e+04. What is the difference between the highest and the second highest Emissions(kt) in 1960?
Your answer should be compact. 2.65e+06. What is the difference between the highest and the second highest Emissions(kt) of 1961?
Offer a very short reply. 2.77e+06. What is the difference between the highest and the second highest Emissions(kt) of 1962?
Provide a short and direct response. 2.91e+06. What is the difference between the highest and the second highest Emissions(kt) of 1963?
Give a very brief answer. 3.12e+06. What is the difference between the highest and the lowest Emissions(kt) in 1960?
Provide a short and direct response. 5.73e+06. What is the difference between the highest and the lowest Emissions(kt) of 1961?
Offer a terse response. 5.85e+06. What is the difference between the highest and the lowest Emissions(kt) of 1962?
Keep it short and to the point. 6.11e+06. What is the difference between the highest and the lowest Emissions(kt) in 1963?
Offer a very short reply. 6.45e+06. 